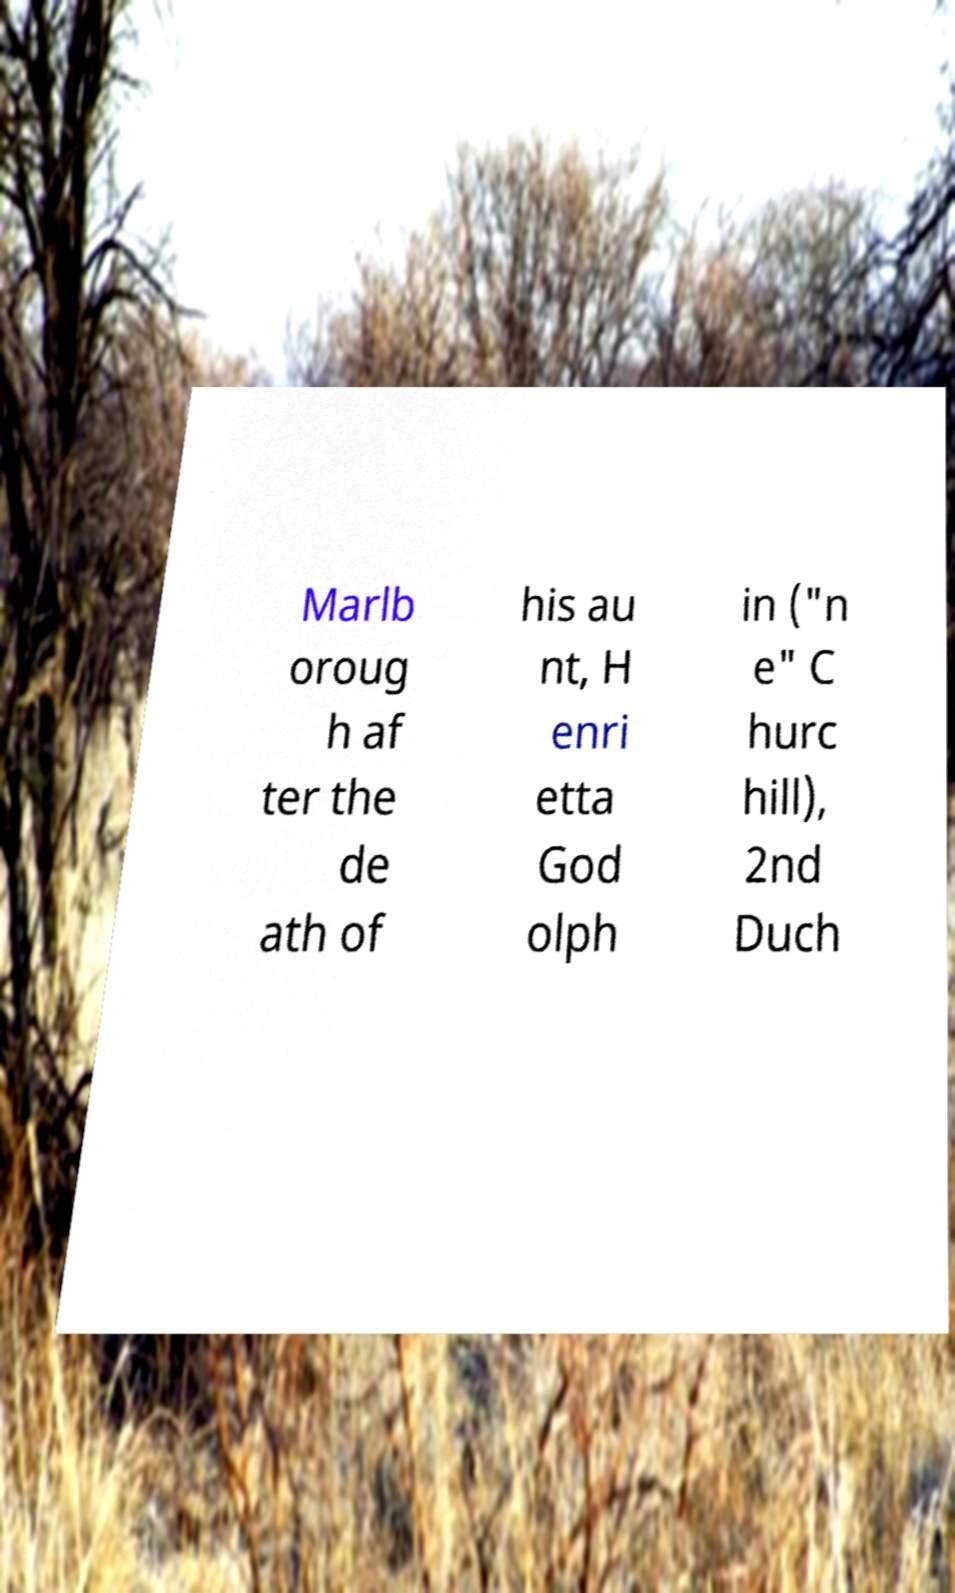What messages or text are displayed in this image? I need them in a readable, typed format. Marlb oroug h af ter the de ath of his au nt, H enri etta God olph in ("n e" C hurc hill), 2nd Duch 